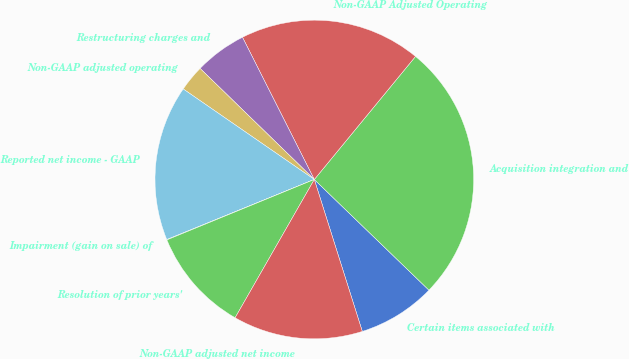<chart> <loc_0><loc_0><loc_500><loc_500><pie_chart><fcel>Certain items associated with<fcel>Acquisition integration and<fcel>Non-GAAP Adjusted Operating<fcel>Restructuring charges and<fcel>Non-GAAP adjusted operating<fcel>Reported net income - GAAP<fcel>Impairment (gain on sale) of<fcel>Resolution of prior years'<fcel>Non-GAAP adjusted net income<nl><fcel>7.91%<fcel>26.27%<fcel>18.4%<fcel>5.28%<fcel>2.66%<fcel>15.77%<fcel>0.04%<fcel>10.53%<fcel>13.15%<nl></chart> 